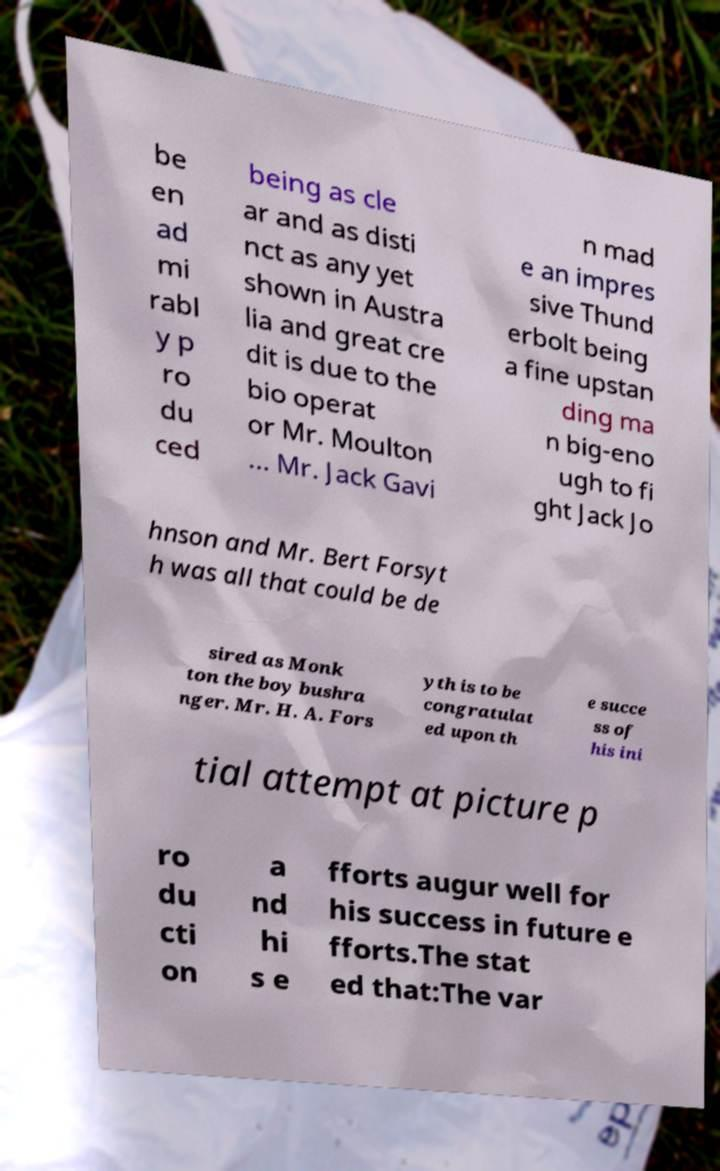For documentation purposes, I need the text within this image transcribed. Could you provide that? be en ad mi rabl y p ro du ced being as cle ar and as disti nct as any yet shown in Austra lia and great cre dit is due to the bio operat or Mr. Moulton ... Mr. Jack Gavi n mad e an impres sive Thund erbolt being a fine upstan ding ma n big-eno ugh to fi ght Jack Jo hnson and Mr. Bert Forsyt h was all that could be de sired as Monk ton the boy bushra nger. Mr. H. A. Fors yth is to be congratulat ed upon th e succe ss of his ini tial attempt at picture p ro du cti on a nd hi s e fforts augur well for his success in future e fforts.The stat ed that:The var 